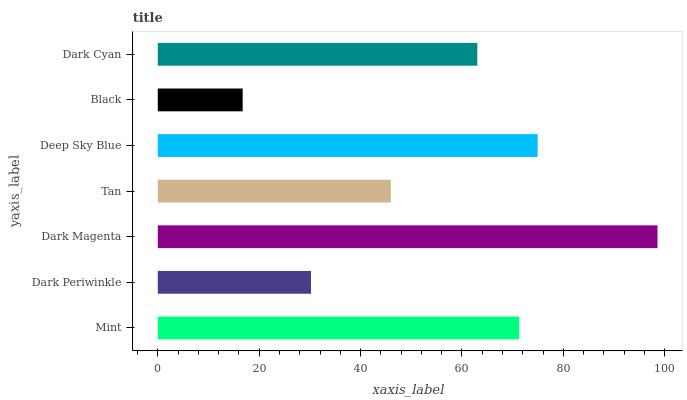Is Black the minimum?
Answer yes or no. Yes. Is Dark Magenta the maximum?
Answer yes or no. Yes. Is Dark Periwinkle the minimum?
Answer yes or no. No. Is Dark Periwinkle the maximum?
Answer yes or no. No. Is Mint greater than Dark Periwinkle?
Answer yes or no. Yes. Is Dark Periwinkle less than Mint?
Answer yes or no. Yes. Is Dark Periwinkle greater than Mint?
Answer yes or no. No. Is Mint less than Dark Periwinkle?
Answer yes or no. No. Is Dark Cyan the high median?
Answer yes or no. Yes. Is Dark Cyan the low median?
Answer yes or no. Yes. Is Tan the high median?
Answer yes or no. No. Is Black the low median?
Answer yes or no. No. 